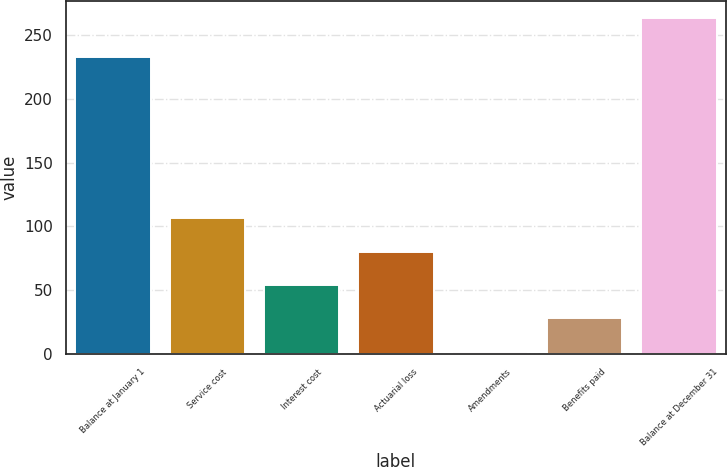Convert chart to OTSL. <chart><loc_0><loc_0><loc_500><loc_500><bar_chart><fcel>Balance at January 1<fcel>Service cost<fcel>Interest cost<fcel>Actuarial loss<fcel>Amendments<fcel>Benefits paid<fcel>Balance at December 31<nl><fcel>233<fcel>106.44<fcel>54.12<fcel>80.28<fcel>1.8<fcel>27.96<fcel>263.4<nl></chart> 